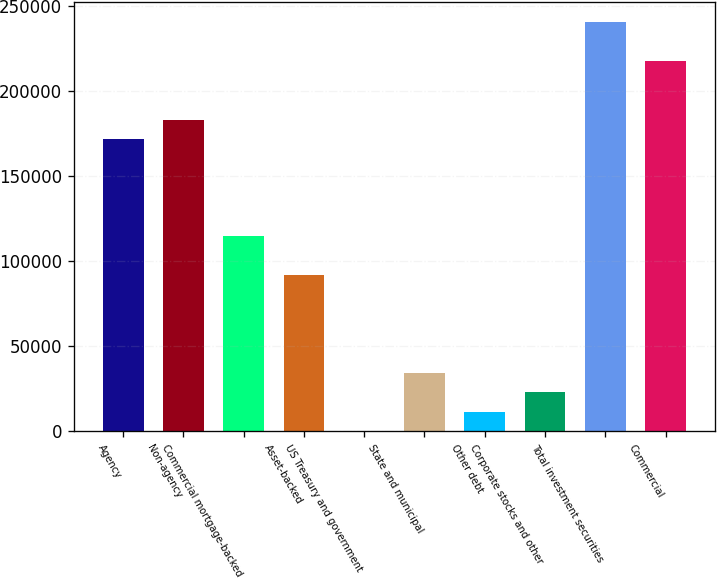Convert chart. <chart><loc_0><loc_0><loc_500><loc_500><bar_chart><fcel>Agency<fcel>Non-agency<fcel>Commercial mortgage-backed<fcel>Asset-backed<fcel>US Treasury and government<fcel>State and municipal<fcel>Other debt<fcel>Corporate stocks and other<fcel>Total investment securities<fcel>Commercial<nl><fcel>171701<fcel>183144<fcel>114484<fcel>91597.2<fcel>50<fcel>34380.2<fcel>11493.4<fcel>22936.8<fcel>240361<fcel>217475<nl></chart> 